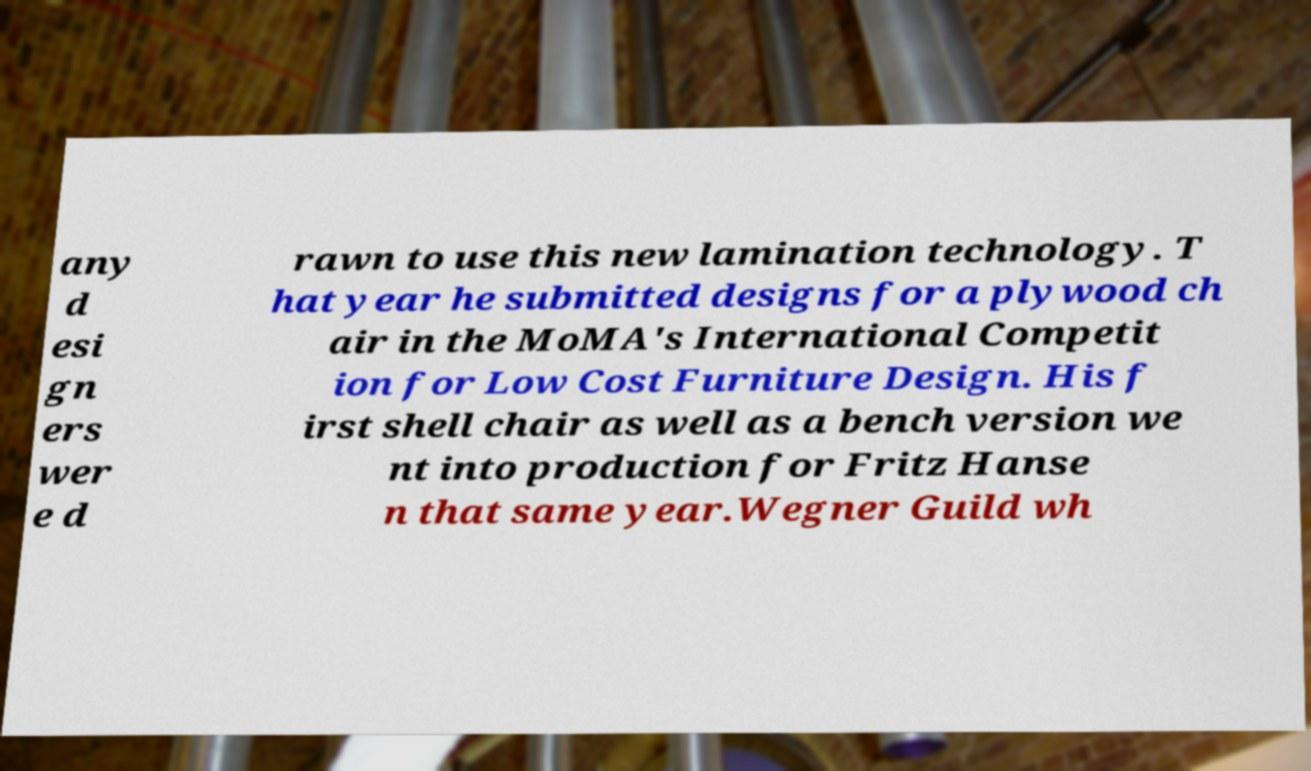For documentation purposes, I need the text within this image transcribed. Could you provide that? any d esi gn ers wer e d rawn to use this new lamination technology. T hat year he submitted designs for a plywood ch air in the MoMA's International Competit ion for Low Cost Furniture Design. His f irst shell chair as well as a bench version we nt into production for Fritz Hanse n that same year.Wegner Guild wh 